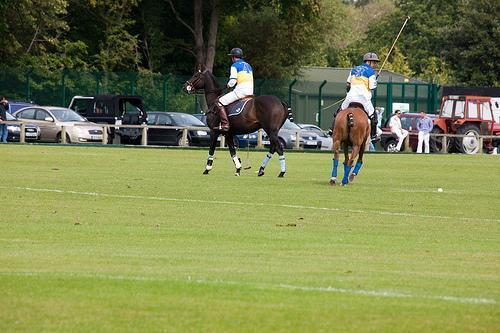How many players are in the photo?
Give a very brief answer. 2. How many horses are in the photograph?
Give a very brief answer. 2. 